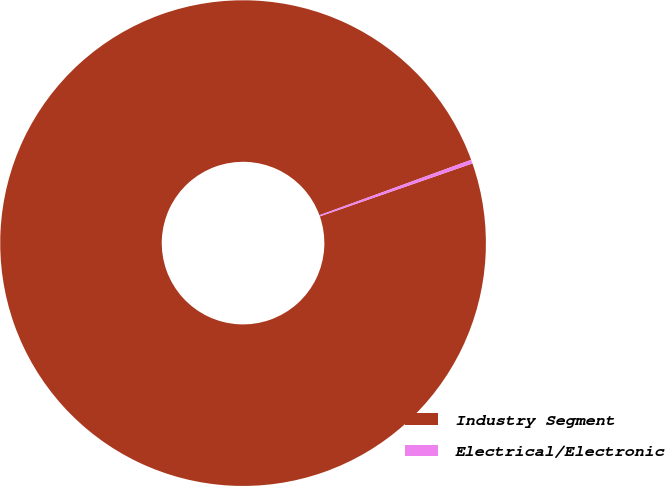Convert chart. <chart><loc_0><loc_0><loc_500><loc_500><pie_chart><fcel>Industry Segment<fcel>Electrical/Electronic<nl><fcel>99.75%<fcel>0.25%<nl></chart> 